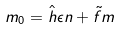Convert formula to latex. <formula><loc_0><loc_0><loc_500><loc_500>m _ { 0 } = \hat { h } \epsilon n + \tilde { f } m</formula> 